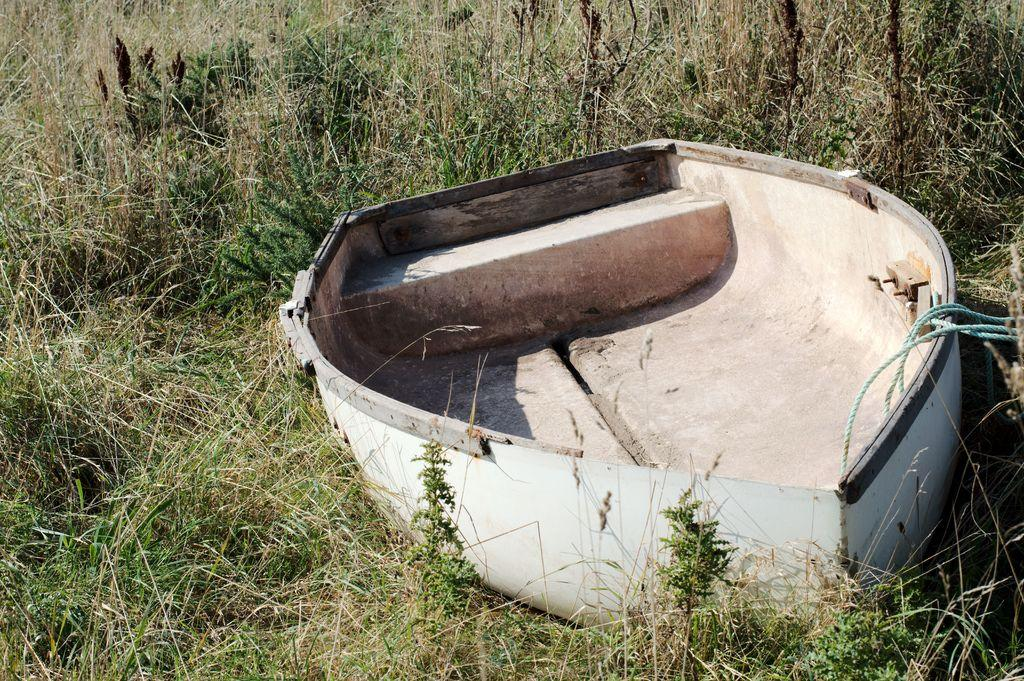What is the main subject of the image? The main subject of the image is a boat. How is the boat secured in the image? The boat is tied with a rope in the image. Where is the boat located in the image? The boat is on land in the image. What type of vegetation covers the land in the image? The land is covered with plants and dried grass in the image. What type of machine is responsible for the wealth expansion in the image? There is no machine, wealth, or expansion mentioned or depicted in the image. 